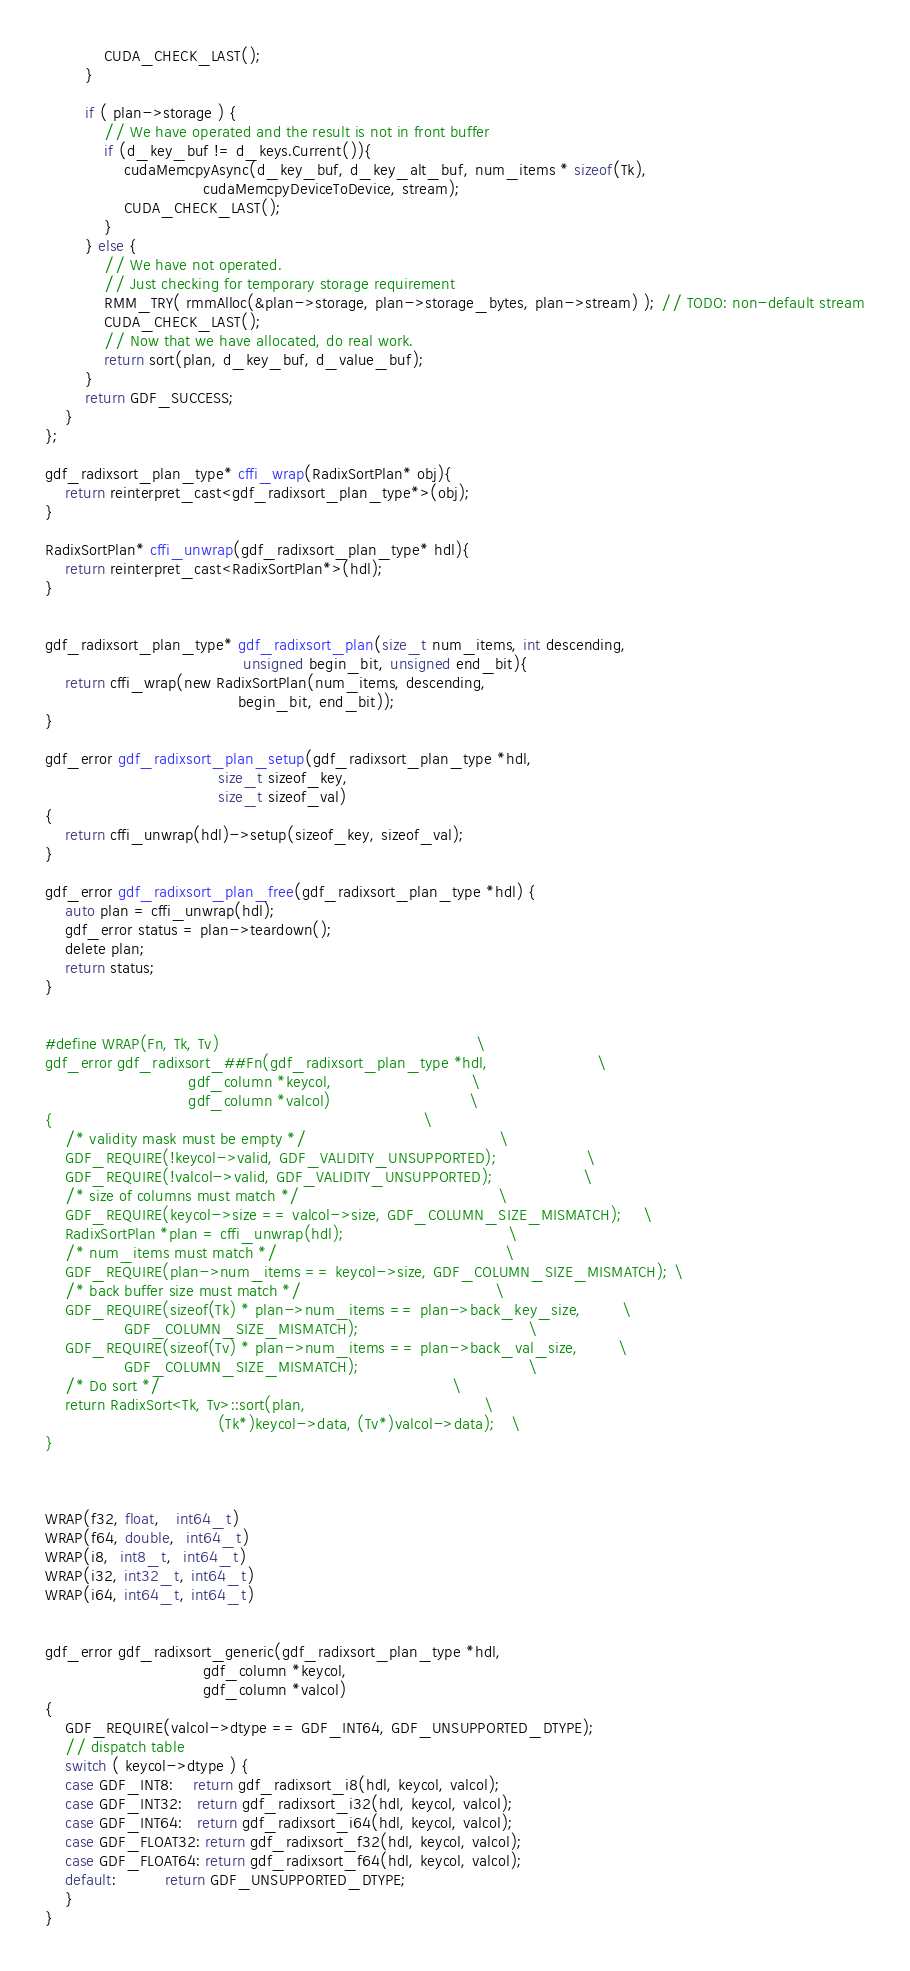<code> <loc_0><loc_0><loc_500><loc_500><_Cuda_>
            CUDA_CHECK_LAST();
        }

        if ( plan->storage ) {
            // We have operated and the result is not in front buffer
            if (d_key_buf != d_keys.Current()){
                cudaMemcpyAsync(d_key_buf, d_key_alt_buf, num_items * sizeof(Tk),
                                cudaMemcpyDeviceToDevice, stream);
                CUDA_CHECK_LAST();
            }
        } else {
            // We have not operated.
            // Just checking for temporary storage requirement
            RMM_TRY( rmmAlloc(&plan->storage, plan->storage_bytes, plan->stream) ); // TODO: non-default stream
            CUDA_CHECK_LAST();
            // Now that we have allocated, do real work.
            return sort(plan, d_key_buf, d_value_buf);
        }
        return GDF_SUCCESS;
    }
};

gdf_radixsort_plan_type* cffi_wrap(RadixSortPlan* obj){
    return reinterpret_cast<gdf_radixsort_plan_type*>(obj);
}

RadixSortPlan* cffi_unwrap(gdf_radixsort_plan_type* hdl){
    return reinterpret_cast<RadixSortPlan*>(hdl);
}


gdf_radixsort_plan_type* gdf_radixsort_plan(size_t num_items, int descending,
                                        unsigned begin_bit, unsigned end_bit){
    return cffi_wrap(new RadixSortPlan(num_items, descending,
                                       begin_bit, end_bit));
}

gdf_error gdf_radixsort_plan_setup(gdf_radixsort_plan_type *hdl,
                                   size_t sizeof_key,
                                   size_t sizeof_val)
{
    return cffi_unwrap(hdl)->setup(sizeof_key, sizeof_val);
}

gdf_error gdf_radixsort_plan_free(gdf_radixsort_plan_type *hdl) {
    auto plan = cffi_unwrap(hdl);
    gdf_error status = plan->teardown();
    delete plan;
    return status;
}


#define WRAP(Fn, Tk, Tv)                                                    \
gdf_error gdf_radixsort_##Fn(gdf_radixsort_plan_type *hdl,                      \
                             gdf_column *keycol,                            \
                             gdf_column *valcol)                            \
{                                                                           \
    /* validity mask must be empty */                                       \
    GDF_REQUIRE(!keycol->valid, GDF_VALIDITY_UNSUPPORTED);                  \
    GDF_REQUIRE(!valcol->valid, GDF_VALIDITY_UNSUPPORTED);                  \
    /* size of columns must match */                                        \
    GDF_REQUIRE(keycol->size == valcol->size, GDF_COLUMN_SIZE_MISMATCH);    \
    RadixSortPlan *plan = cffi_unwrap(hdl);                                 \
    /* num_items must match */                                              \
    GDF_REQUIRE(plan->num_items == keycol->size, GDF_COLUMN_SIZE_MISMATCH); \
    /* back buffer size must match */                                       \
    GDF_REQUIRE(sizeof(Tk) * plan->num_items == plan->back_key_size,        \
                GDF_COLUMN_SIZE_MISMATCH);                                  \
    GDF_REQUIRE(sizeof(Tv) * plan->num_items == plan->back_val_size,        \
                GDF_COLUMN_SIZE_MISMATCH);                                  \
    /* Do sort */                                                           \
    return RadixSort<Tk, Tv>::sort(plan,                                    \
                                   (Tk*)keycol->data, (Tv*)valcol->data);   \
}



WRAP(f32, float,   int64_t)
WRAP(f64, double,  int64_t)
WRAP(i8,  int8_t,  int64_t)
WRAP(i32, int32_t, int64_t)
WRAP(i64, int64_t, int64_t)


gdf_error gdf_radixsort_generic(gdf_radixsort_plan_type *hdl,
                                gdf_column *keycol,
                                gdf_column *valcol)
{
    GDF_REQUIRE(valcol->dtype == GDF_INT64, GDF_UNSUPPORTED_DTYPE);
    // dispatch table
    switch ( keycol->dtype ) {
    case GDF_INT8:    return gdf_radixsort_i8(hdl, keycol, valcol);
    case GDF_INT32:   return gdf_radixsort_i32(hdl, keycol, valcol);
    case GDF_INT64:   return gdf_radixsort_i64(hdl, keycol, valcol);
    case GDF_FLOAT32: return gdf_radixsort_f32(hdl, keycol, valcol);
    case GDF_FLOAT64: return gdf_radixsort_f64(hdl, keycol, valcol);
    default:          return GDF_UNSUPPORTED_DTYPE;
    }
}

</code> 